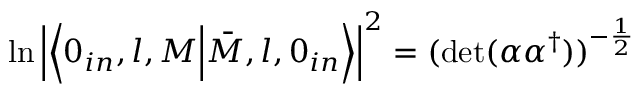<formula> <loc_0><loc_0><loc_500><loc_500>\ln \left | \left \langle 0 _ { i n } , l , M \Big | \bar { M } , l , 0 _ { i n } \right \rangle \right | ^ { 2 } = ( d e t ( \alpha \alpha ^ { \dagger } ) ) ^ { - \frac { 1 } { 2 } }</formula> 